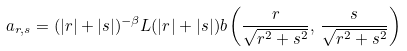<formula> <loc_0><loc_0><loc_500><loc_500>a _ { r , s } = ( | r | + | s | ) ^ { - \beta } L ( | r | + | s | ) b \left ( \frac { r } { \sqrt { r ^ { 2 } + s ^ { 2 } } } , \, \frac { s } { \sqrt { r ^ { 2 } + s ^ { 2 } } } \right )</formula> 